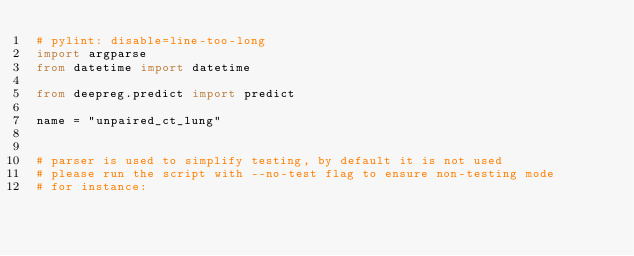<code> <loc_0><loc_0><loc_500><loc_500><_Python_># pylint: disable=line-too-long
import argparse
from datetime import datetime

from deepreg.predict import predict

name = "unpaired_ct_lung"


# parser is used to simplify testing, by default it is not used
# please run the script with --no-test flag to ensure non-testing mode
# for instance:</code> 